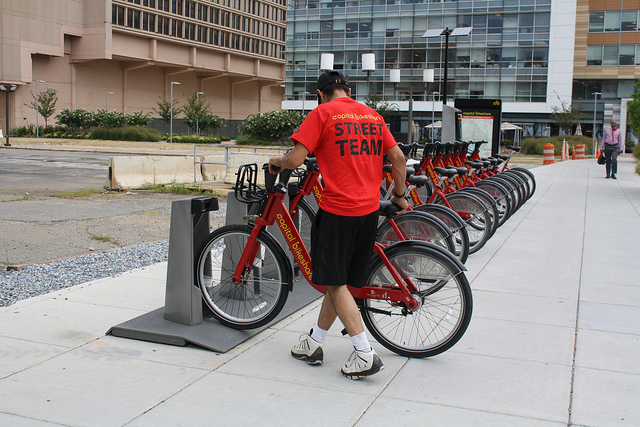Identify the text contained in this image. STREET TEAM capial BIKE 